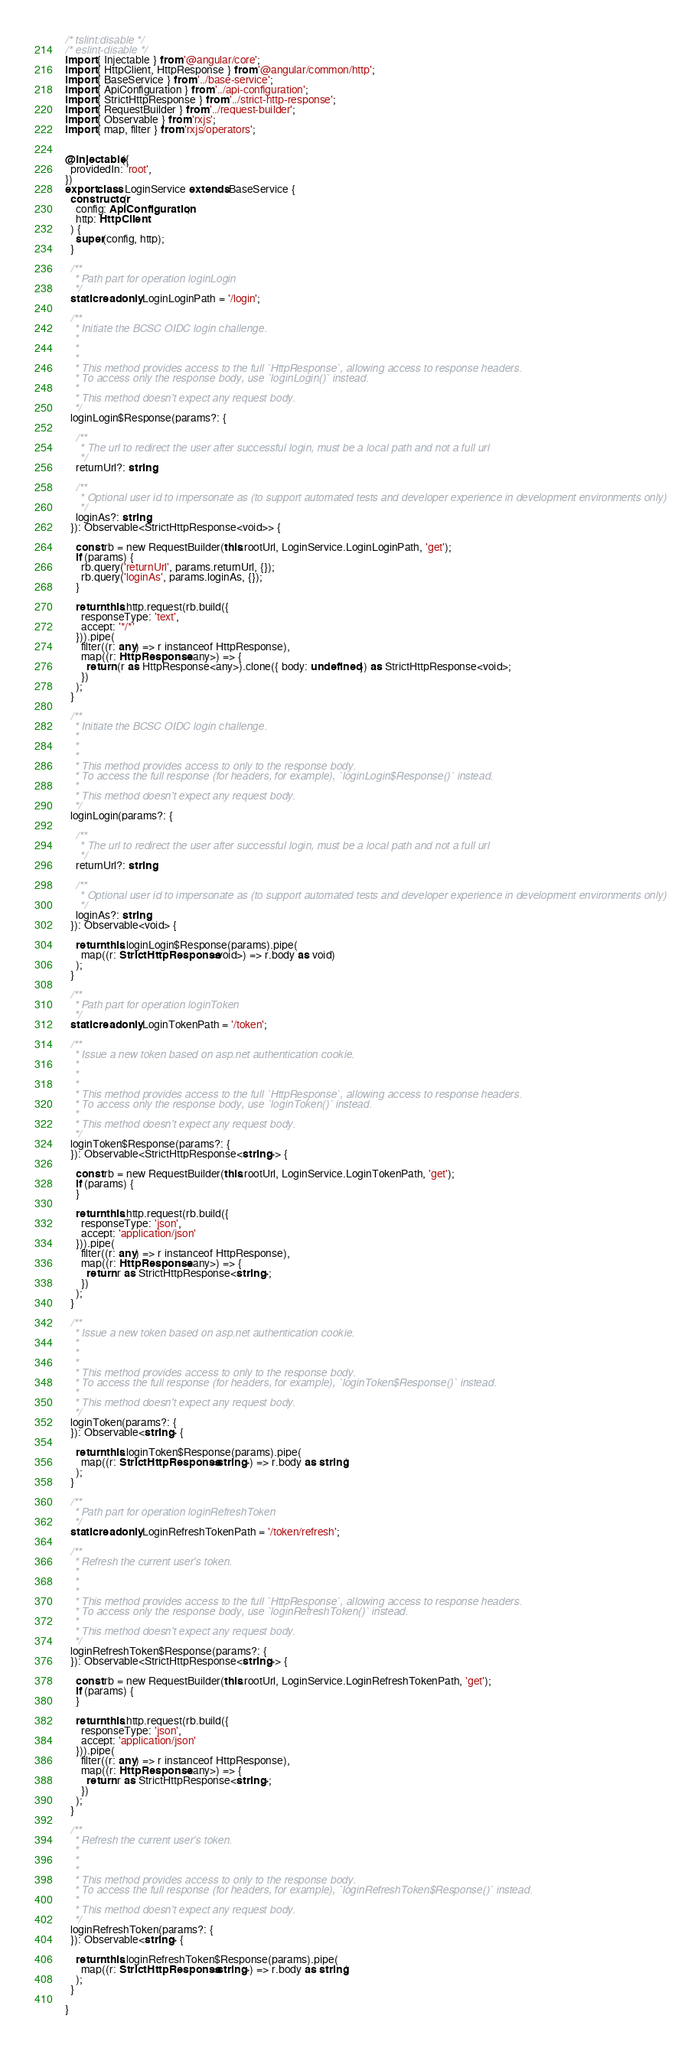<code> <loc_0><loc_0><loc_500><loc_500><_TypeScript_>/* tslint:disable */
/* eslint-disable */
import { Injectable } from '@angular/core';
import { HttpClient, HttpResponse } from '@angular/common/http';
import { BaseService } from '../base-service';
import { ApiConfiguration } from '../api-configuration';
import { StrictHttpResponse } from '../strict-http-response';
import { RequestBuilder } from '../request-builder';
import { Observable } from 'rxjs';
import { map, filter } from 'rxjs/operators';


@Injectable({
  providedIn: 'root',
})
export class LoginService extends BaseService {
  constructor(
    config: ApiConfiguration,
    http: HttpClient
  ) {
    super(config, http);
  }

  /**
   * Path part for operation loginLogin
   */
  static readonly LoginLoginPath = '/login';

  /**
   * Initiate the BCSC OIDC login challenge.
   *
   *
   *
   * This method provides access to the full `HttpResponse`, allowing access to response headers.
   * To access only the response body, use `loginLogin()` instead.
   *
   * This method doesn't expect any request body.
   */
  loginLogin$Response(params?: {

    /**
     * The url to redirect the user after successful login, must be a local path and not a full url
     */
    returnUrl?: string;

    /**
     * Optional user id to impersonate as (to support automated tests and developer experience in development environments only)
     */
    loginAs?: string;
  }): Observable<StrictHttpResponse<void>> {

    const rb = new RequestBuilder(this.rootUrl, LoginService.LoginLoginPath, 'get');
    if (params) {
      rb.query('returnUrl', params.returnUrl, {});
      rb.query('loginAs', params.loginAs, {});
    }

    return this.http.request(rb.build({
      responseType: 'text',
      accept: '*/*'
    })).pipe(
      filter((r: any) => r instanceof HttpResponse),
      map((r: HttpResponse<any>) => {
        return (r as HttpResponse<any>).clone({ body: undefined }) as StrictHttpResponse<void>;
      })
    );
  }

  /**
   * Initiate the BCSC OIDC login challenge.
   *
   *
   *
   * This method provides access to only to the response body.
   * To access the full response (for headers, for example), `loginLogin$Response()` instead.
   *
   * This method doesn't expect any request body.
   */
  loginLogin(params?: {

    /**
     * The url to redirect the user after successful login, must be a local path and not a full url
     */
    returnUrl?: string;

    /**
     * Optional user id to impersonate as (to support automated tests and developer experience in development environments only)
     */
    loginAs?: string;
  }): Observable<void> {

    return this.loginLogin$Response(params).pipe(
      map((r: StrictHttpResponse<void>) => r.body as void)
    );
  }

  /**
   * Path part for operation loginToken
   */
  static readonly LoginTokenPath = '/token';

  /**
   * Issue a new token based on asp.net authentication cookie.
   *
   *
   *
   * This method provides access to the full `HttpResponse`, allowing access to response headers.
   * To access only the response body, use `loginToken()` instead.
   *
   * This method doesn't expect any request body.
   */
  loginToken$Response(params?: {
  }): Observable<StrictHttpResponse<string>> {

    const rb = new RequestBuilder(this.rootUrl, LoginService.LoginTokenPath, 'get');
    if (params) {
    }

    return this.http.request(rb.build({
      responseType: 'json',
      accept: 'application/json'
    })).pipe(
      filter((r: any) => r instanceof HttpResponse),
      map((r: HttpResponse<any>) => {
        return r as StrictHttpResponse<string>;
      })
    );
  }

  /**
   * Issue a new token based on asp.net authentication cookie.
   *
   *
   *
   * This method provides access to only to the response body.
   * To access the full response (for headers, for example), `loginToken$Response()` instead.
   *
   * This method doesn't expect any request body.
   */
  loginToken(params?: {
  }): Observable<string> {

    return this.loginToken$Response(params).pipe(
      map((r: StrictHttpResponse<string>) => r.body as string)
    );
  }

  /**
   * Path part for operation loginRefreshToken
   */
  static readonly LoginRefreshTokenPath = '/token/refresh';

  /**
   * Refresh the current user's token.
   *
   *
   *
   * This method provides access to the full `HttpResponse`, allowing access to response headers.
   * To access only the response body, use `loginRefreshToken()` instead.
   *
   * This method doesn't expect any request body.
   */
  loginRefreshToken$Response(params?: {
  }): Observable<StrictHttpResponse<string>> {

    const rb = new RequestBuilder(this.rootUrl, LoginService.LoginRefreshTokenPath, 'get');
    if (params) {
    }

    return this.http.request(rb.build({
      responseType: 'json',
      accept: 'application/json'
    })).pipe(
      filter((r: any) => r instanceof HttpResponse),
      map((r: HttpResponse<any>) => {
        return r as StrictHttpResponse<string>;
      })
    );
  }

  /**
   * Refresh the current user's token.
   *
   *
   *
   * This method provides access to only to the response body.
   * To access the full response (for headers, for example), `loginRefreshToken$Response()` instead.
   *
   * This method doesn't expect any request body.
   */
  loginRefreshToken(params?: {
  }): Observable<string> {

    return this.loginRefreshToken$Response(params).pipe(
      map((r: StrictHttpResponse<string>) => r.body as string)
    );
  }

}
</code> 